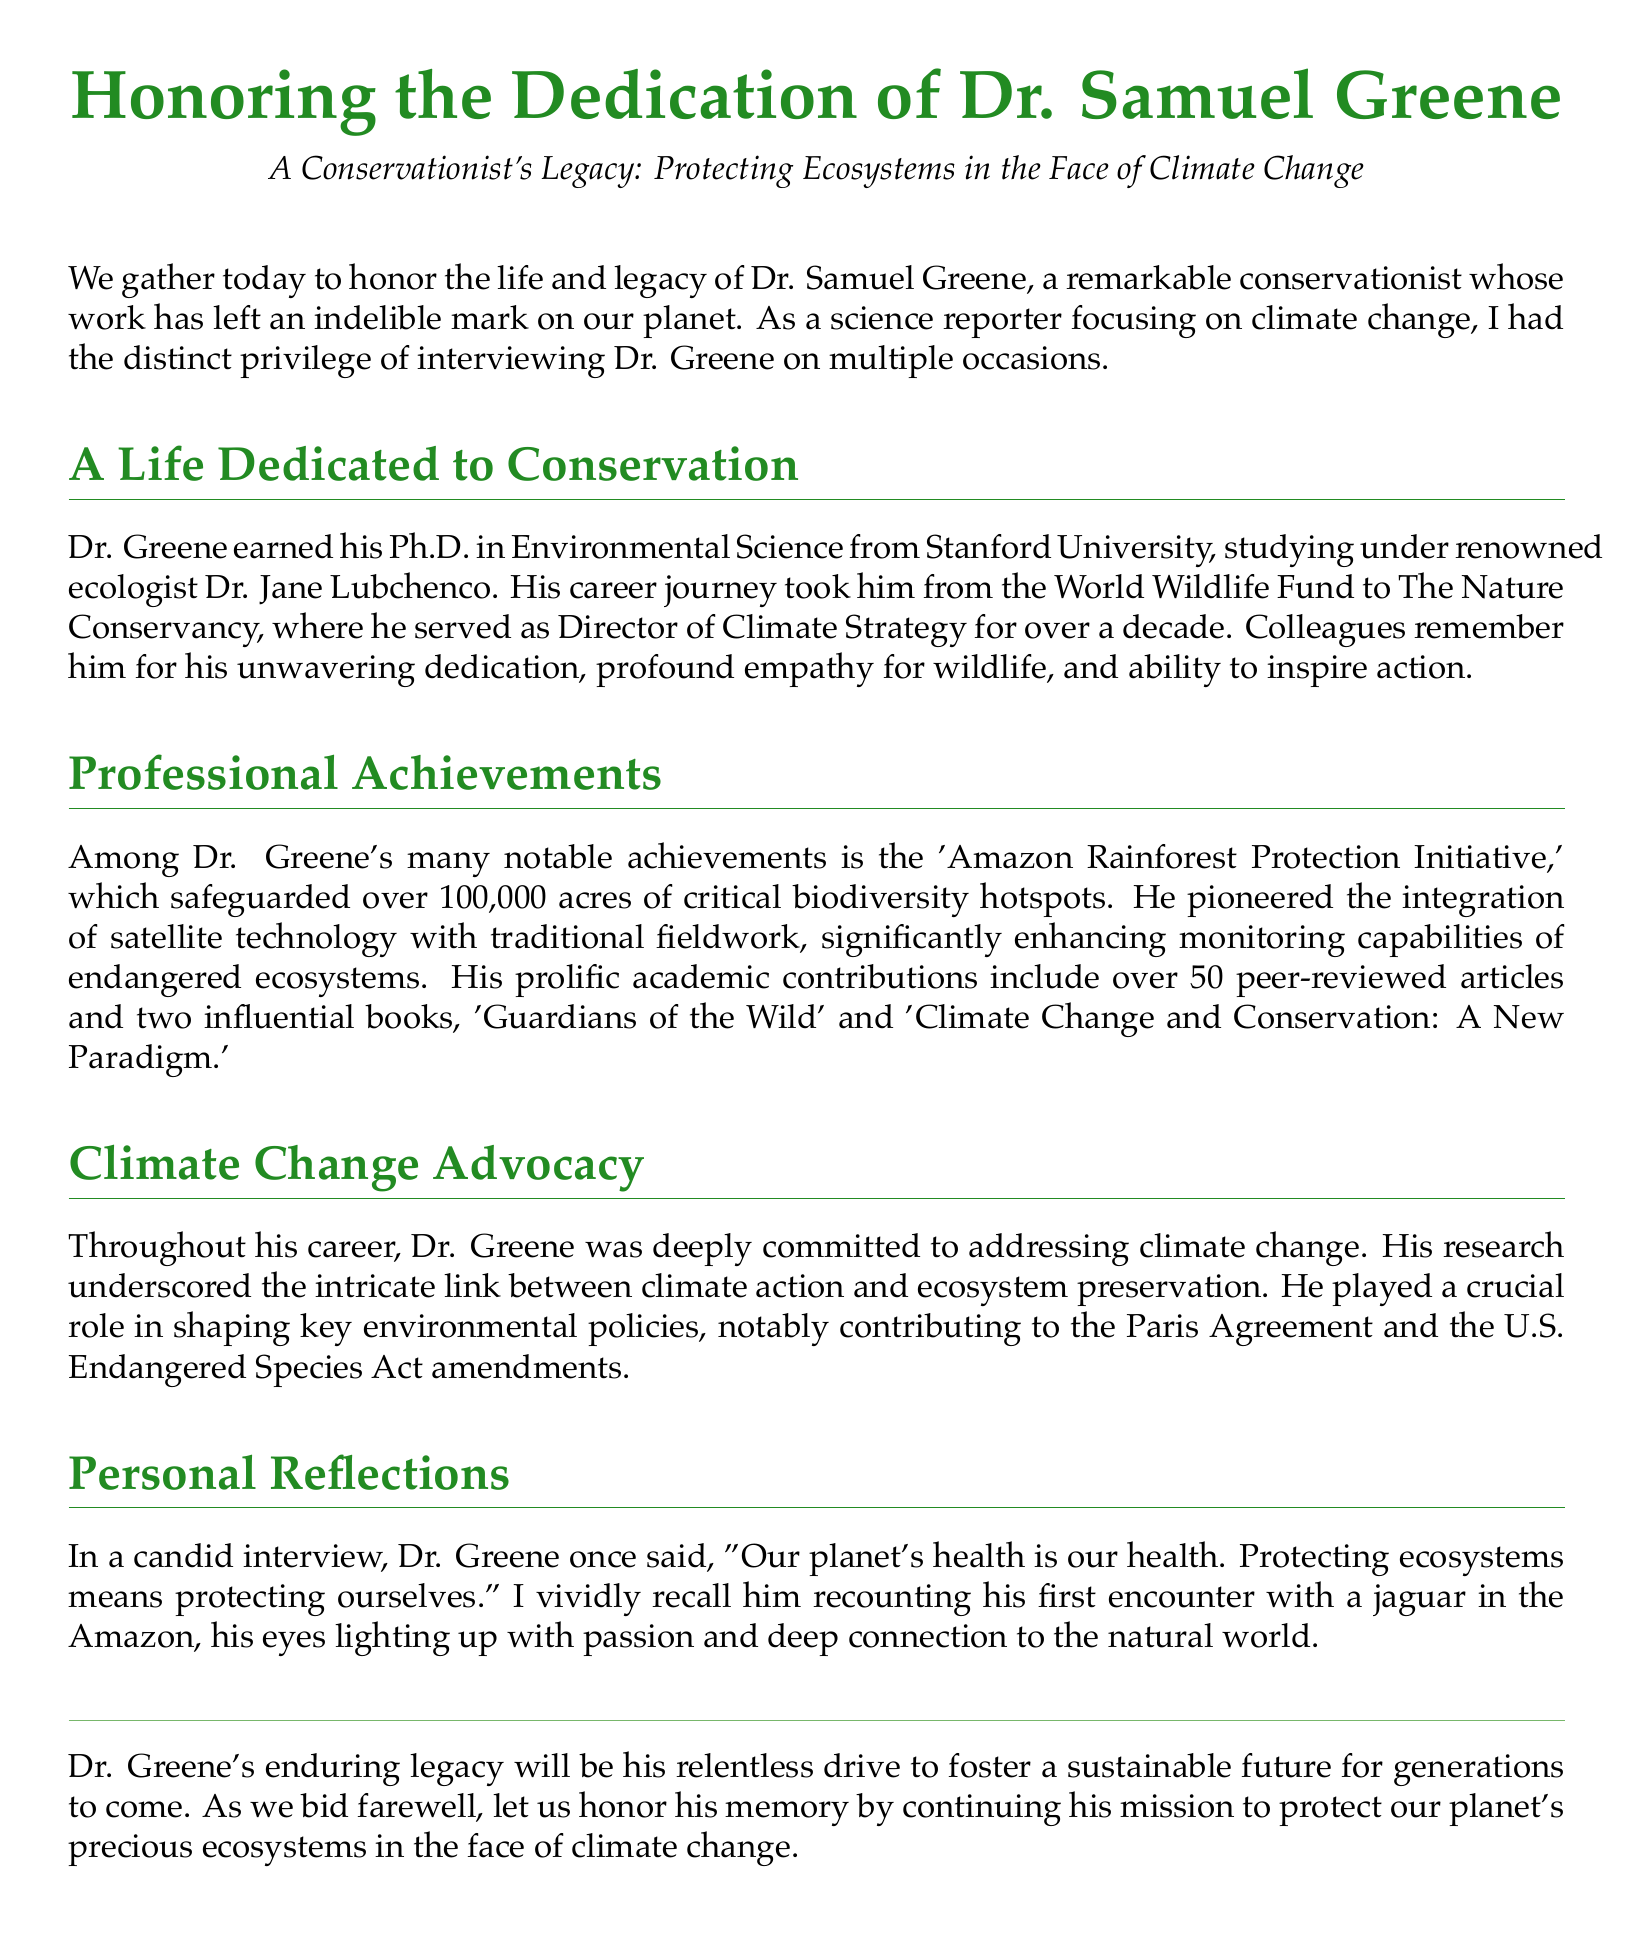What was Dr. Samuel Greene's field of study? Dr. Greene earned his Ph.D. in Environmental Science.
Answer: Environmental Science What organization did Dr. Greene work for as Director of Climate Strategy? He served as Director of Climate Strategy at The Nature Conservancy.
Answer: The Nature Conservancy How many peer-reviewed articles did Dr. Greene publish? His academic contributions include over 50 peer-reviewed articles.
Answer: Over 50 Which significant environmental policy did Dr. Greene contribute to? He played a crucial role in shaping key environmental policies, notably contributing to the Paris Agreement.
Answer: Paris Agreement What was the focus of the 'Amazon Rainforest Protection Initiative'? The initiative safeguarded over 100,000 acres of critical biodiversity hotspots.
Answer: Over 100,000 acres Why is Dr. Greene's work considered vital in facing climate change? His research underscored the intricate link between climate action and ecosystem preservation.
Answer: Ecosystem preservation What did Dr. Greene believe protecting ecosystems meant for humanity? "Protecting ecosystems means protecting ourselves."
Answer: Protecting ourselves What personal experience did Dr. Greene share that illustrated his passion for wildlife? He recounted his first encounter with a jaguar in the Amazon.
Answer: First encounter with a jaguar 